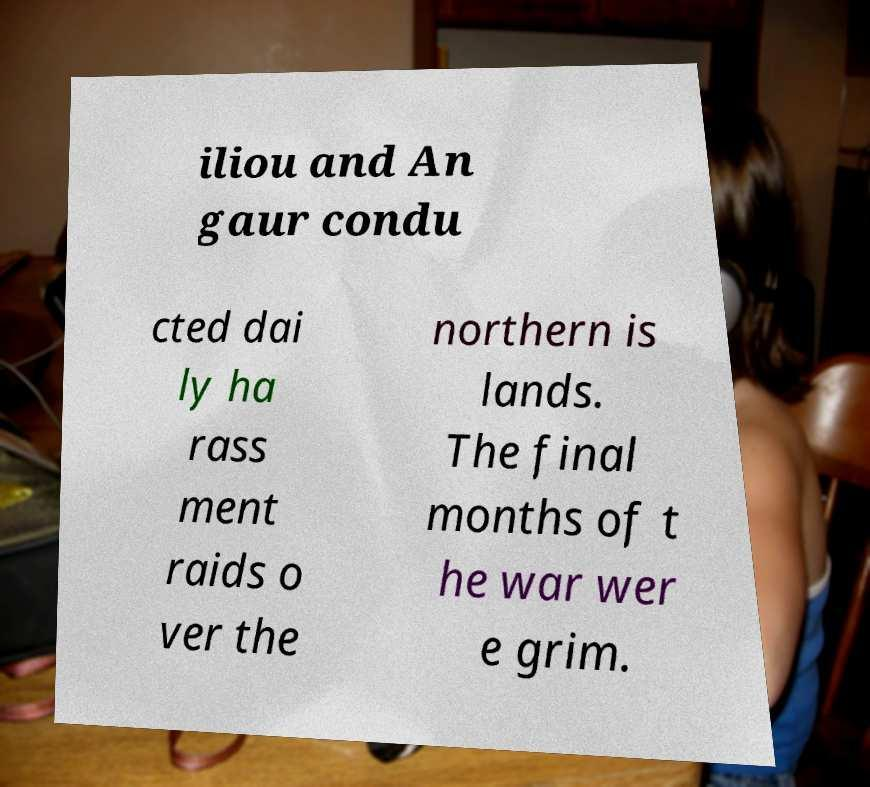Could you assist in decoding the text presented in this image and type it out clearly? iliou and An gaur condu cted dai ly ha rass ment raids o ver the northern is lands. The final months of t he war wer e grim. 